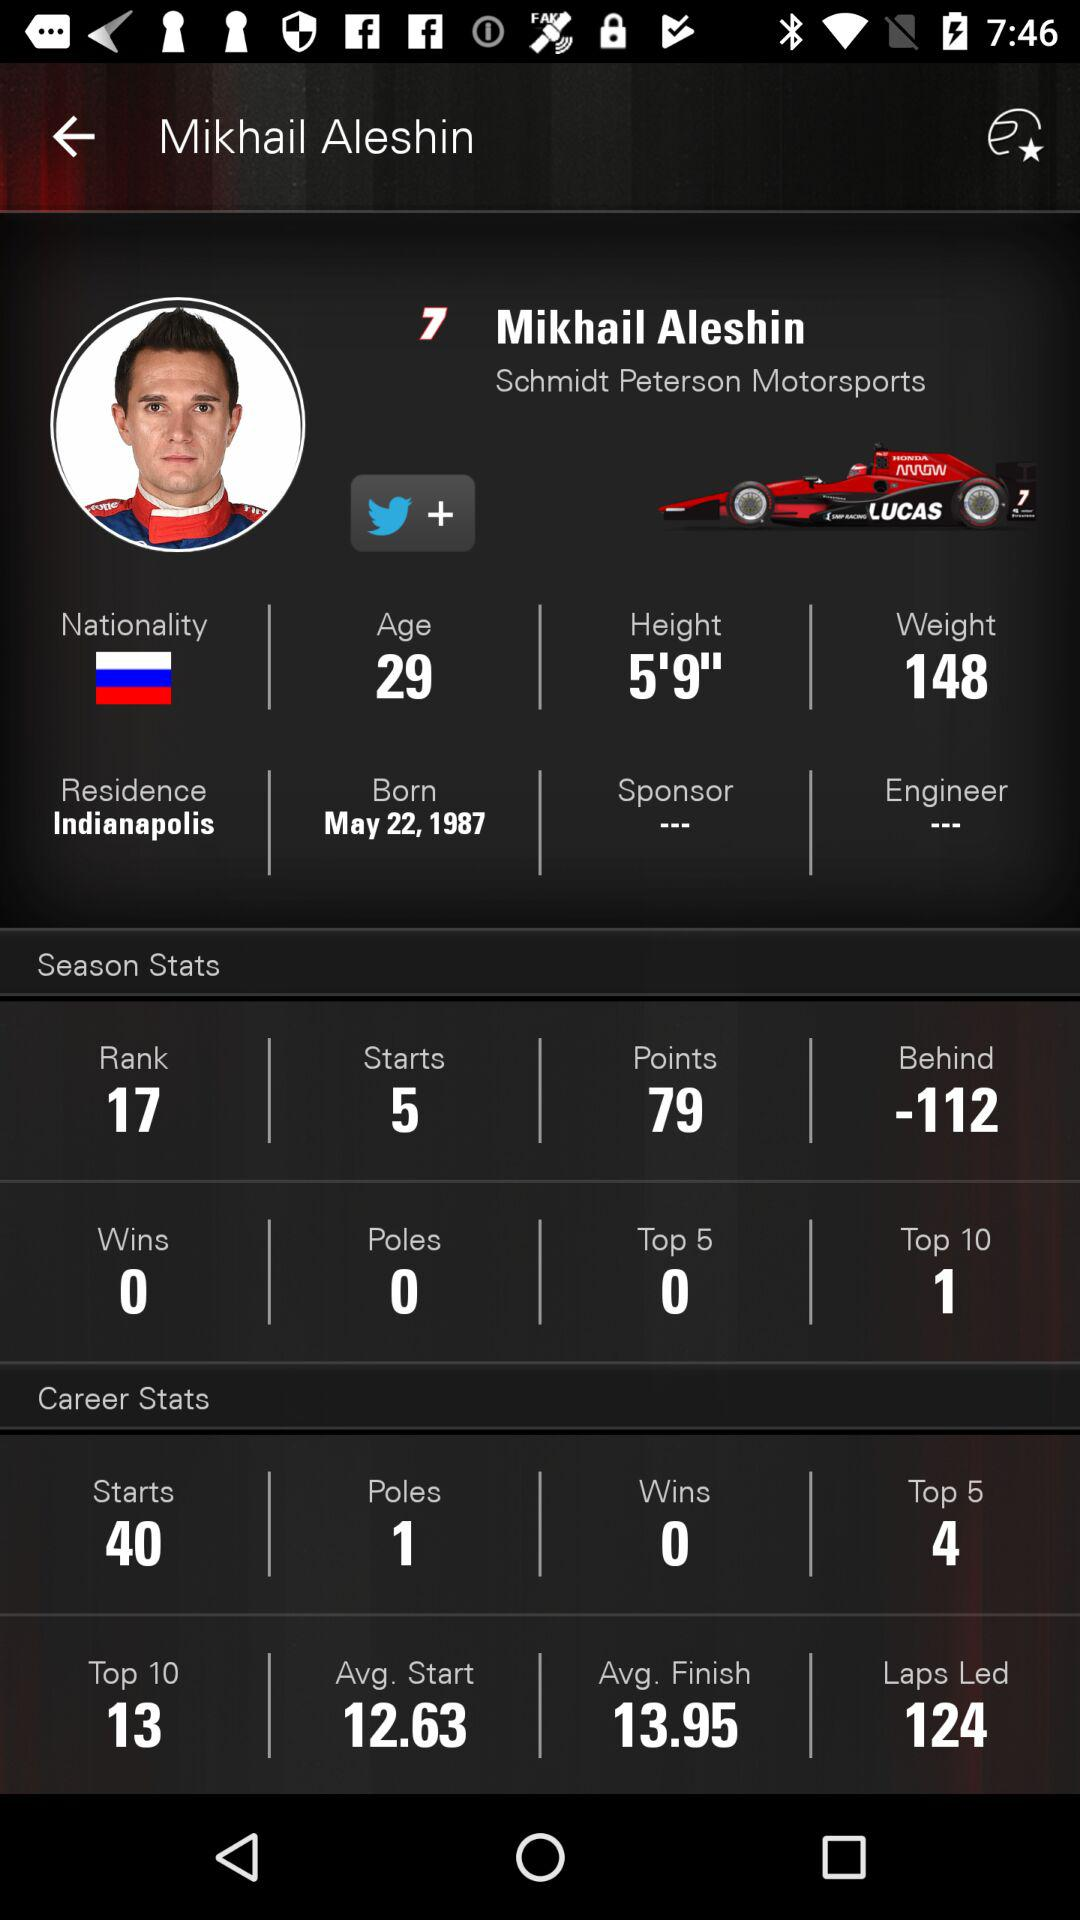What is the nationality of Mikhail Aleshin? The nationality is Russian. 